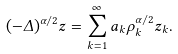<formula> <loc_0><loc_0><loc_500><loc_500>( - \Delta ) ^ { \alpha / 2 } z = \sum _ { k = 1 } ^ { \infty } a _ { k } \rho _ { k } ^ { \alpha / 2 } z _ { k } .</formula> 